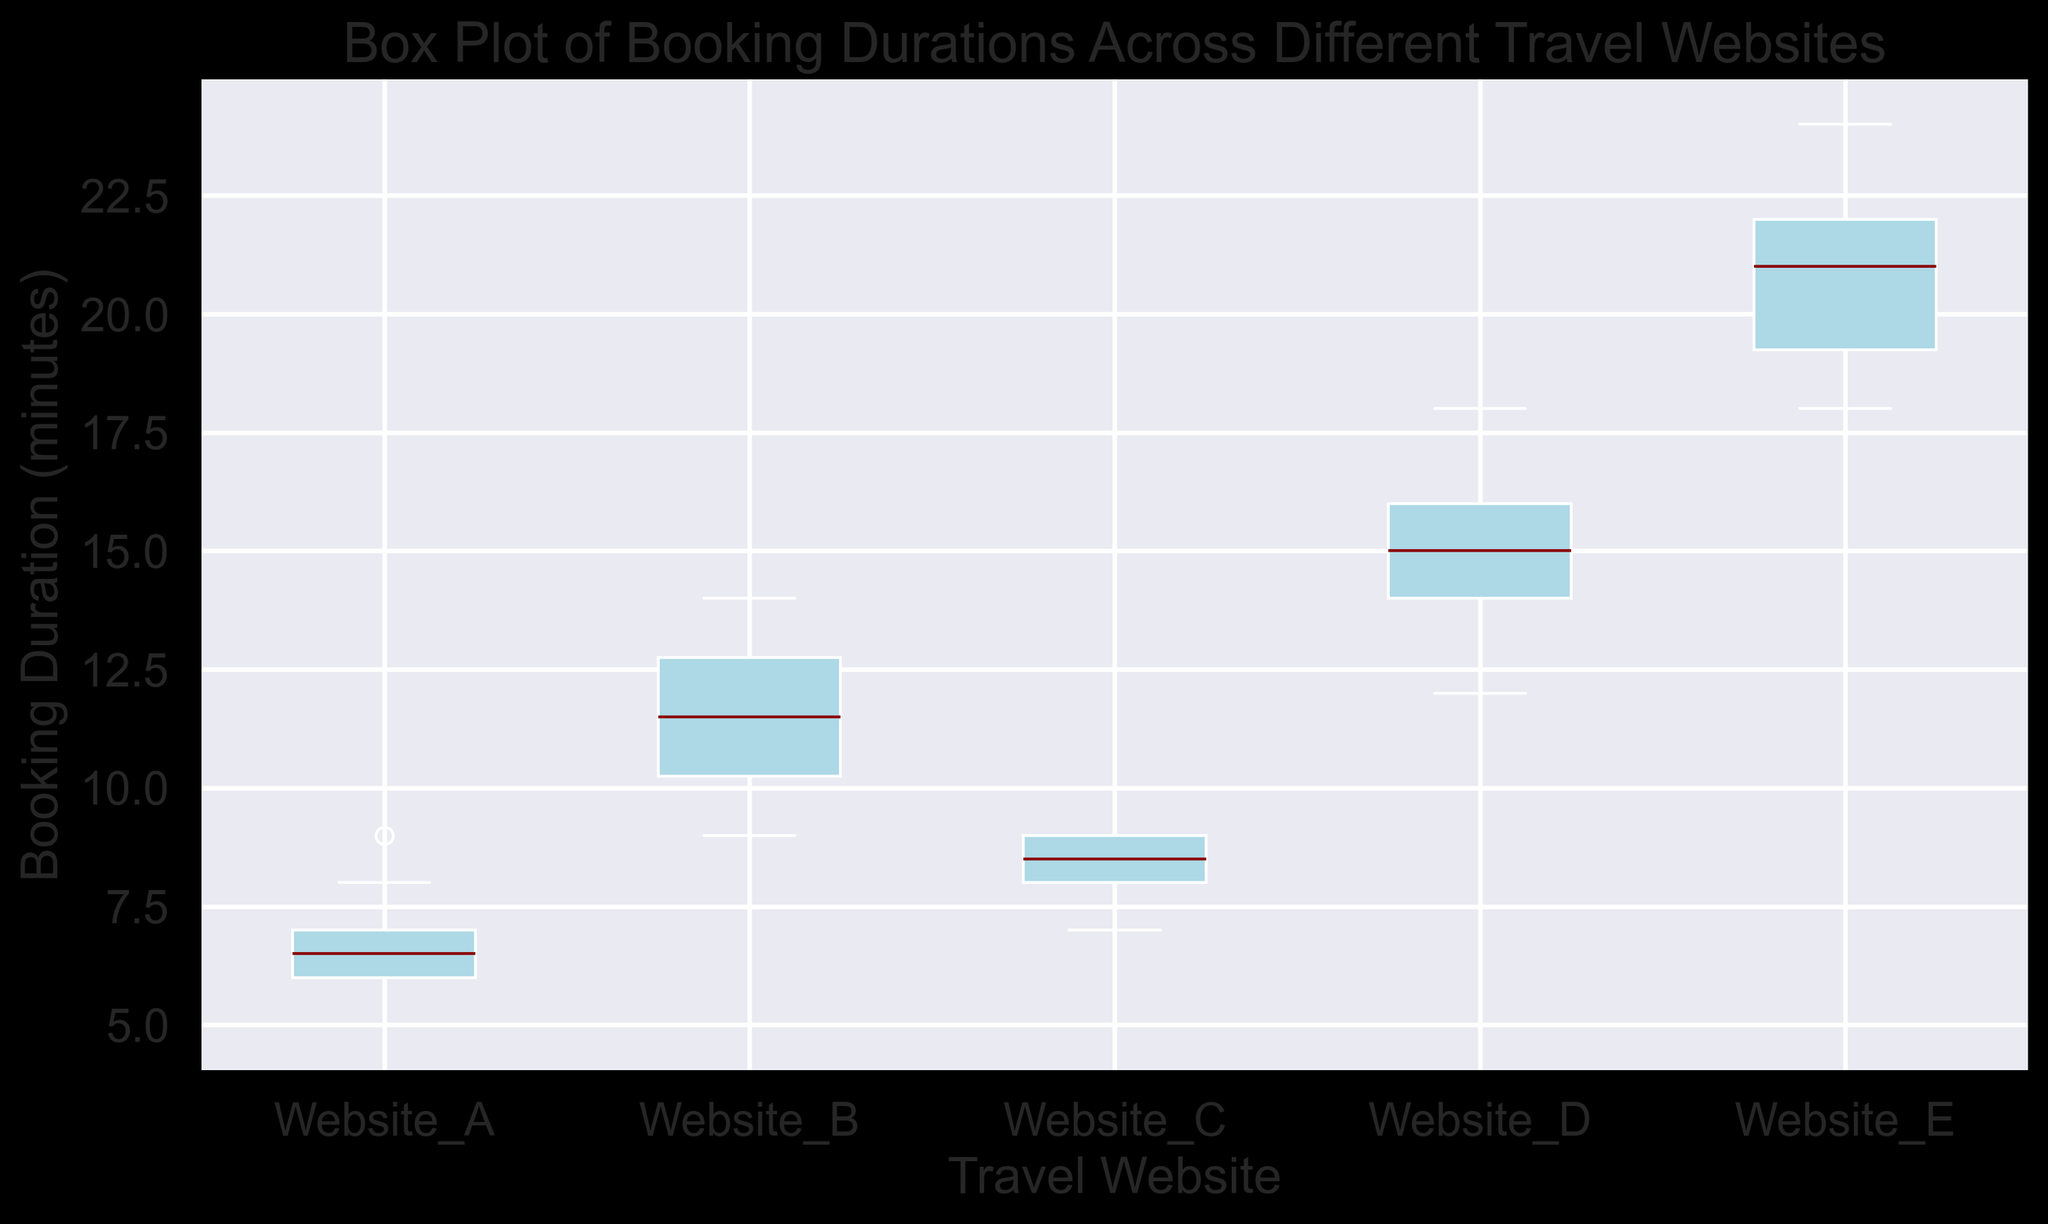What travel website has the shortest median booking duration? To find the travel website with the shortest median booking duration, look for the box plot with the lowest median line. This line is represented by a dark red color.
Answer: Website_A Which travel website has the widest range of booking durations? The range is represented by the distance between the lower whisker and upper whisker in the box plot. The website with the longest distance between these whiskers has the widest range.
Answer: Website_E What is the interquartile range (IQR) for Website_C? The IQR is calculated as the difference between the third quartile (Q3) and the first quartile (Q1). Identify the top and bottom lines of the box for Website_C and calculate the difference.
Answer: 2 Compare the median booking durations of Website_A and Website_D. Which one is shorter? Identify the median lines (dark red) for both Website_A and Website_D box plots. The shorter line indicates a shorter duration.
Answer: Website_A Which website shows the most consistency in booking durations? The most consistent website will have the smallest interquartile range (IQR), meaning the box is the narrowest.
Answer: Website_A Are there any outliers visible in the box plot for Website_E? Outliers are data points that fall outside the whiskers of the box plot. For Website_E, check if there are any data points that are noticeably far from the whiskers.
Answer: No Rank the travel websites based on their median booking durations from shortest to longest. To rank the websites, look at the median lines (dark red) of each box plot and arrange them from the lowest to highest.
Answer: Website_A, Website_C, Website_B, Website_D, Website_E Calculate the difference between the maximum booking durations of Website_D and Website_B. The maximum booking duration is represented by the top whisker of each box plot. Identify the top whiskers for Website_D and Website_B, then subtract the value of Website_B from Website_D.
Answer: 8 What is the median booking duration for Website_A? The median booking duration is represented by the dark red line within the box for Website_A.
Answer: 7 